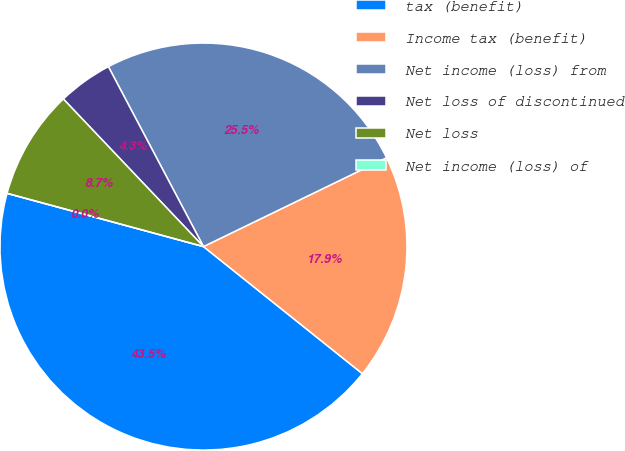Convert chart to OTSL. <chart><loc_0><loc_0><loc_500><loc_500><pie_chart><fcel>tax (benefit)<fcel>Income tax (benefit)<fcel>Net income (loss) from<fcel>Net loss of discontinued<fcel>Net loss<fcel>Net income (loss) of<nl><fcel>43.48%<fcel>17.93%<fcel>25.55%<fcel>4.35%<fcel>8.7%<fcel>0.0%<nl></chart> 